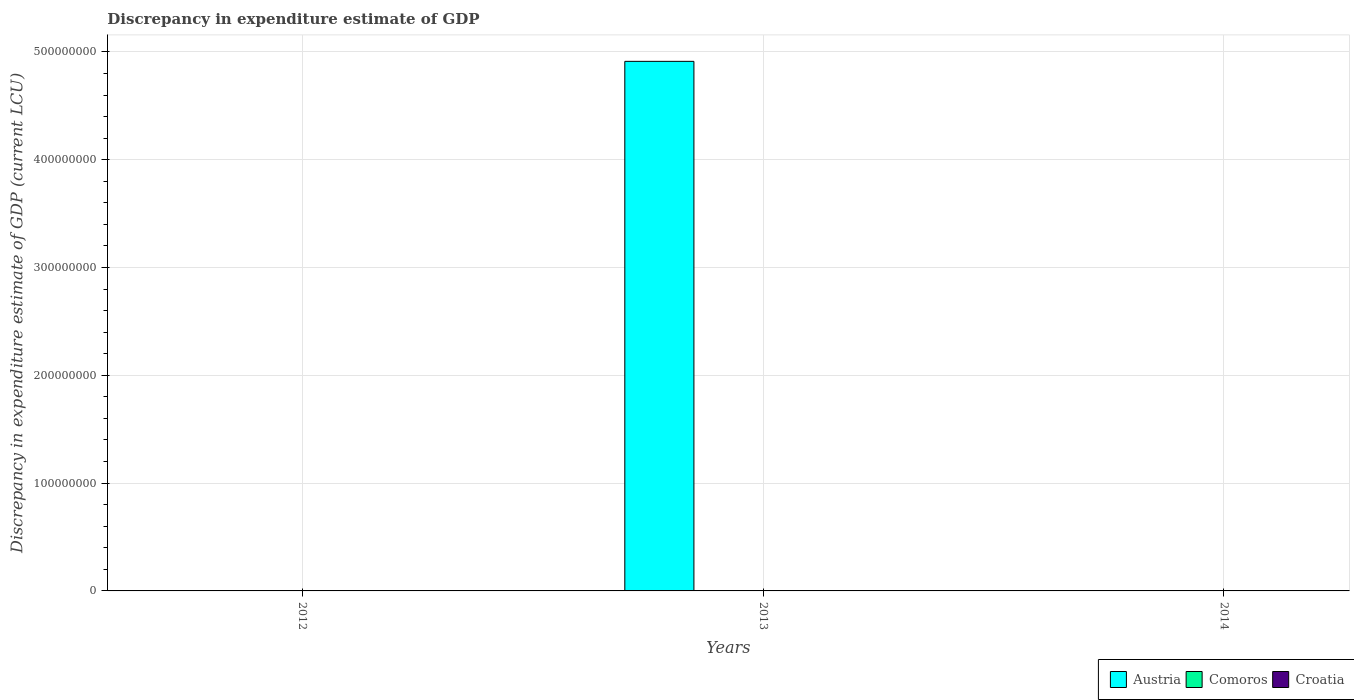How many different coloured bars are there?
Make the answer very short. 1. Are the number of bars per tick equal to the number of legend labels?
Your answer should be very brief. No. How many bars are there on the 1st tick from the right?
Provide a short and direct response. 0. What is the label of the 2nd group of bars from the left?
Keep it short and to the point. 2013. In how many cases, is the number of bars for a given year not equal to the number of legend labels?
Offer a terse response. 3. What is the discrepancy in expenditure estimate of GDP in Austria in 2013?
Ensure brevity in your answer.  4.91e+08. Across all years, what is the maximum discrepancy in expenditure estimate of GDP in Austria?
Your answer should be very brief. 4.91e+08. Across all years, what is the minimum discrepancy in expenditure estimate of GDP in Comoros?
Offer a very short reply. 0. What is the total discrepancy in expenditure estimate of GDP in Austria in the graph?
Make the answer very short. 4.91e+08. What is the difference between the discrepancy in expenditure estimate of GDP in Croatia in 2014 and the discrepancy in expenditure estimate of GDP in Comoros in 2012?
Your answer should be compact. 0. What is the difference between the highest and the lowest discrepancy in expenditure estimate of GDP in Austria?
Your answer should be compact. 4.91e+08. In how many years, is the discrepancy in expenditure estimate of GDP in Comoros greater than the average discrepancy in expenditure estimate of GDP in Comoros taken over all years?
Offer a terse response. 0. Is it the case that in every year, the sum of the discrepancy in expenditure estimate of GDP in Croatia and discrepancy in expenditure estimate of GDP in Comoros is greater than the discrepancy in expenditure estimate of GDP in Austria?
Offer a terse response. No. How many bars are there?
Give a very brief answer. 1. What is the difference between two consecutive major ticks on the Y-axis?
Ensure brevity in your answer.  1.00e+08. Does the graph contain grids?
Your answer should be compact. Yes. Where does the legend appear in the graph?
Ensure brevity in your answer.  Bottom right. How many legend labels are there?
Provide a short and direct response. 3. How are the legend labels stacked?
Your answer should be very brief. Horizontal. What is the title of the graph?
Make the answer very short. Discrepancy in expenditure estimate of GDP. Does "Greenland" appear as one of the legend labels in the graph?
Give a very brief answer. No. What is the label or title of the X-axis?
Provide a short and direct response. Years. What is the label or title of the Y-axis?
Offer a very short reply. Discrepancy in expenditure estimate of GDP (current LCU). What is the Discrepancy in expenditure estimate of GDP (current LCU) in Austria in 2012?
Ensure brevity in your answer.  0. What is the Discrepancy in expenditure estimate of GDP (current LCU) in Austria in 2013?
Give a very brief answer. 4.91e+08. What is the Discrepancy in expenditure estimate of GDP (current LCU) in Comoros in 2013?
Provide a short and direct response. 0. What is the Discrepancy in expenditure estimate of GDP (current LCU) in Croatia in 2014?
Give a very brief answer. 0. Across all years, what is the maximum Discrepancy in expenditure estimate of GDP (current LCU) in Austria?
Offer a very short reply. 4.91e+08. Across all years, what is the minimum Discrepancy in expenditure estimate of GDP (current LCU) of Austria?
Offer a terse response. 0. What is the total Discrepancy in expenditure estimate of GDP (current LCU) in Austria in the graph?
Your answer should be very brief. 4.91e+08. What is the total Discrepancy in expenditure estimate of GDP (current LCU) in Comoros in the graph?
Offer a terse response. 0. What is the total Discrepancy in expenditure estimate of GDP (current LCU) in Croatia in the graph?
Make the answer very short. 0. What is the average Discrepancy in expenditure estimate of GDP (current LCU) of Austria per year?
Give a very brief answer. 1.64e+08. What is the average Discrepancy in expenditure estimate of GDP (current LCU) in Comoros per year?
Your answer should be compact. 0. What is the average Discrepancy in expenditure estimate of GDP (current LCU) in Croatia per year?
Give a very brief answer. 0. What is the difference between the highest and the lowest Discrepancy in expenditure estimate of GDP (current LCU) of Austria?
Offer a terse response. 4.91e+08. 